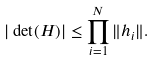Convert formula to latex. <formula><loc_0><loc_0><loc_500><loc_500>| \det ( H ) | \leq \prod _ { i = 1 } ^ { N } \| h _ { i } \| .</formula> 